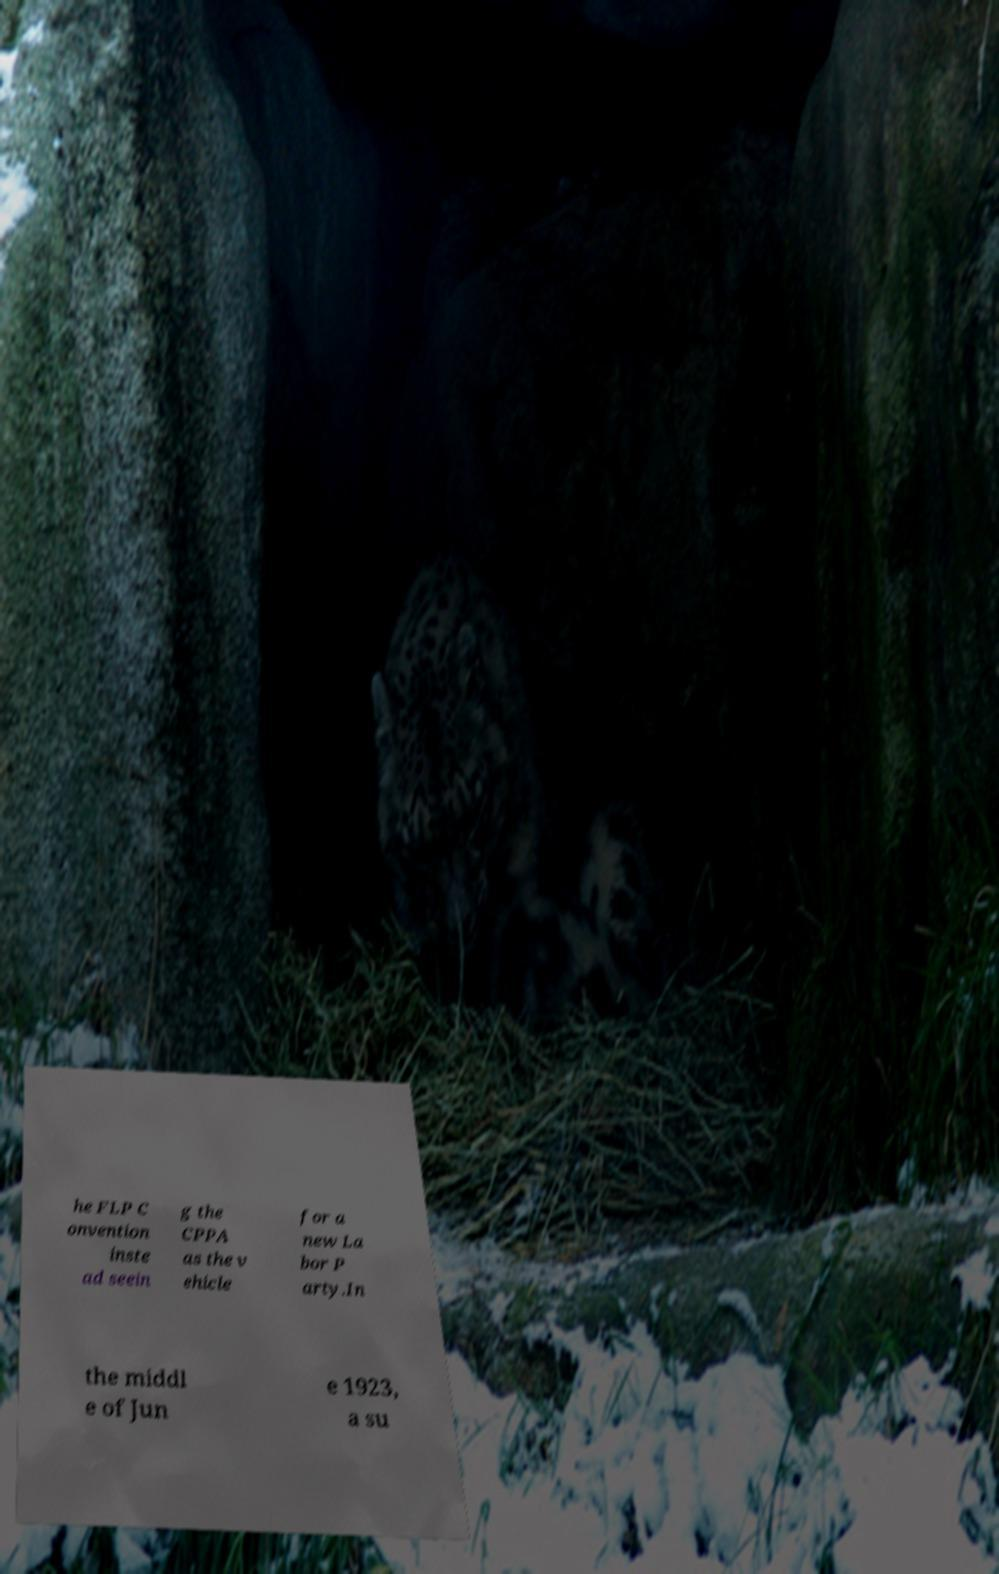Can you read and provide the text displayed in the image?This photo seems to have some interesting text. Can you extract and type it out for me? he FLP C onvention inste ad seein g the CPPA as the v ehicle for a new La bor P arty.In the middl e of Jun e 1923, a su 